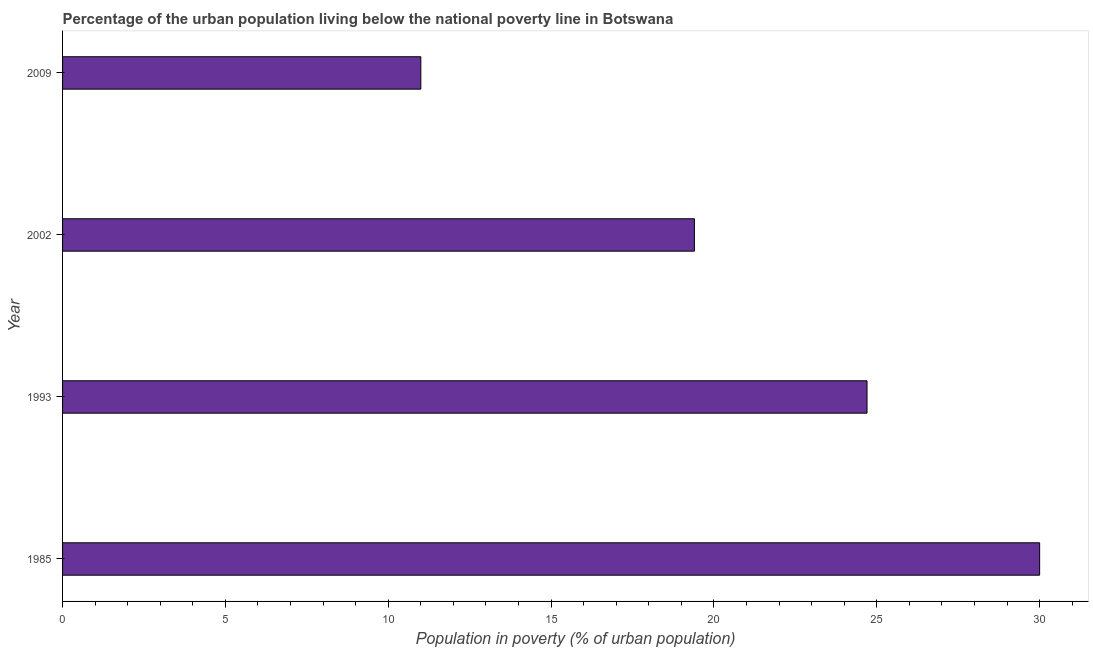Does the graph contain any zero values?
Give a very brief answer. No. What is the title of the graph?
Keep it short and to the point. Percentage of the urban population living below the national poverty line in Botswana. What is the label or title of the X-axis?
Your response must be concise. Population in poverty (% of urban population). What is the percentage of urban population living below poverty line in 1993?
Your answer should be very brief. 24.7. Across all years, what is the maximum percentage of urban population living below poverty line?
Offer a very short reply. 30. In which year was the percentage of urban population living below poverty line maximum?
Provide a short and direct response. 1985. In which year was the percentage of urban population living below poverty line minimum?
Your response must be concise. 2009. What is the sum of the percentage of urban population living below poverty line?
Your answer should be compact. 85.1. What is the average percentage of urban population living below poverty line per year?
Provide a succinct answer. 21.27. What is the median percentage of urban population living below poverty line?
Make the answer very short. 22.05. What is the ratio of the percentage of urban population living below poverty line in 1985 to that in 2009?
Offer a terse response. 2.73. Is the percentage of urban population living below poverty line in 2002 less than that in 2009?
Provide a succinct answer. No. Is the difference between the percentage of urban population living below poverty line in 1993 and 2002 greater than the difference between any two years?
Your answer should be compact. No. What is the difference between the highest and the lowest percentage of urban population living below poverty line?
Keep it short and to the point. 19. In how many years, is the percentage of urban population living below poverty line greater than the average percentage of urban population living below poverty line taken over all years?
Your answer should be very brief. 2. How many bars are there?
Your answer should be very brief. 4. How many years are there in the graph?
Offer a terse response. 4. What is the difference between two consecutive major ticks on the X-axis?
Give a very brief answer. 5. Are the values on the major ticks of X-axis written in scientific E-notation?
Ensure brevity in your answer.  No. What is the Population in poverty (% of urban population) in 1985?
Provide a short and direct response. 30. What is the Population in poverty (% of urban population) in 1993?
Provide a succinct answer. 24.7. What is the difference between the Population in poverty (% of urban population) in 1993 and 2009?
Keep it short and to the point. 13.7. What is the ratio of the Population in poverty (% of urban population) in 1985 to that in 1993?
Ensure brevity in your answer.  1.22. What is the ratio of the Population in poverty (% of urban population) in 1985 to that in 2002?
Provide a succinct answer. 1.55. What is the ratio of the Population in poverty (% of urban population) in 1985 to that in 2009?
Provide a short and direct response. 2.73. What is the ratio of the Population in poverty (% of urban population) in 1993 to that in 2002?
Make the answer very short. 1.27. What is the ratio of the Population in poverty (% of urban population) in 1993 to that in 2009?
Make the answer very short. 2.25. What is the ratio of the Population in poverty (% of urban population) in 2002 to that in 2009?
Offer a very short reply. 1.76. 